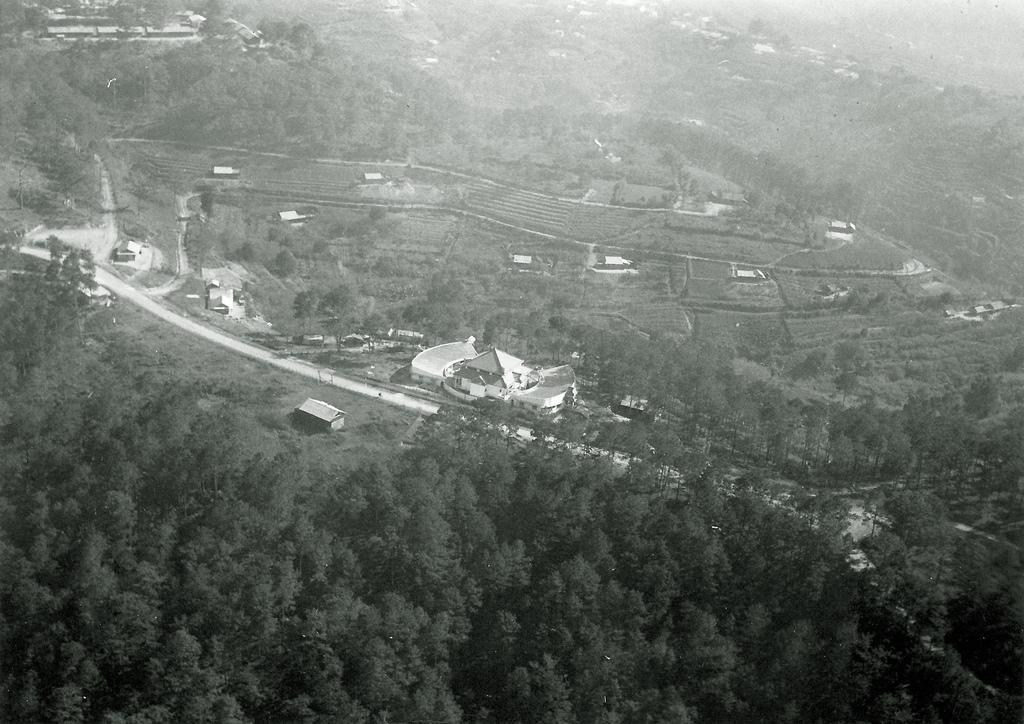Could you give a brief overview of what you see in this image? In this image I can see a road in the centre. I can also see number of trees, number of buildings and I can see this image is black and white in colour. 